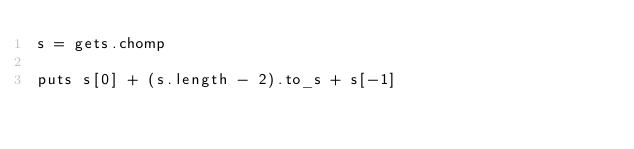Convert code to text. <code><loc_0><loc_0><loc_500><loc_500><_Ruby_>s = gets.chomp

puts s[0] + (s.length - 2).to_s + s[-1]</code> 